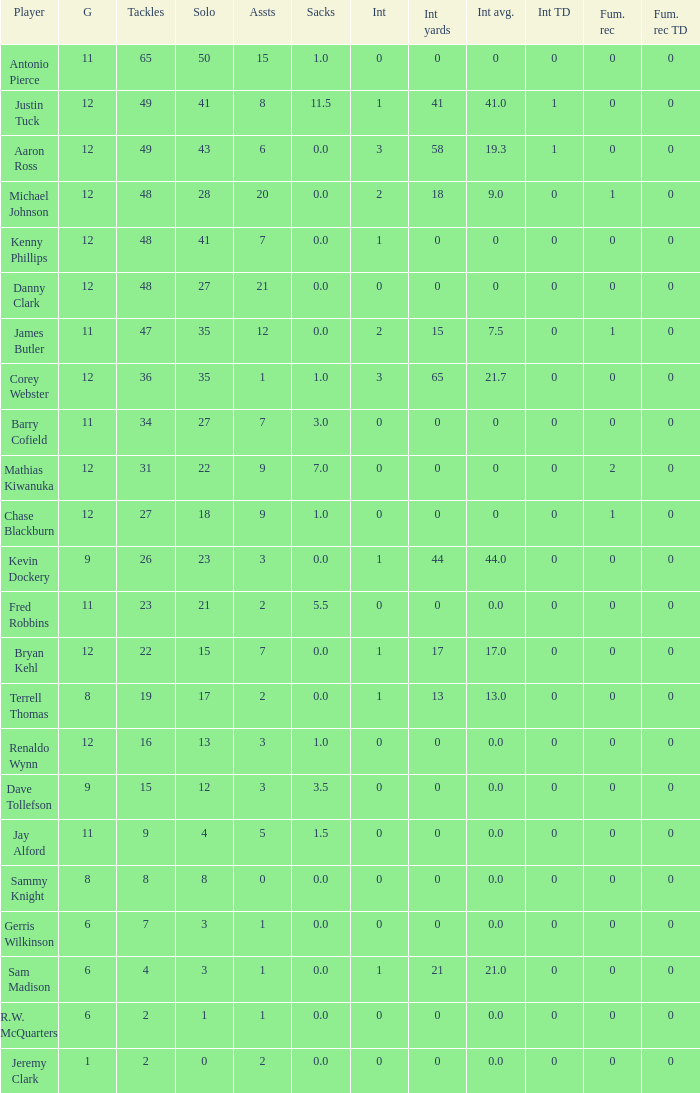Name the most tackles for 3.5 sacks 15.0. 